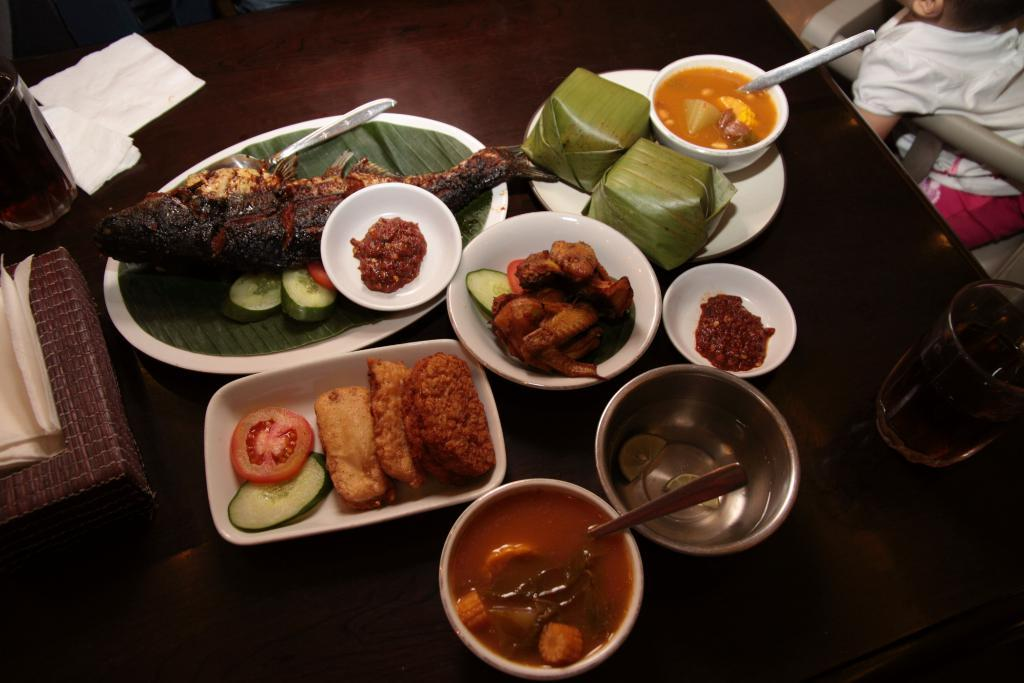What types of food can be seen in the image? There are food items in the image, which are in plates and bowls. What colors are present in the food items? The food has colors such as brown, red, white, and orange. What else can be seen on the table in the image? There are objects on the table in the image. How many ladybugs are crawling on the food in the image? There are no ladybugs present in the image; it only features food items in plates and bowls. What type of pollution can be seen in the image? There is no pollution visible in the image; it only contains food items, plates, bowls, and other objects on the table. 